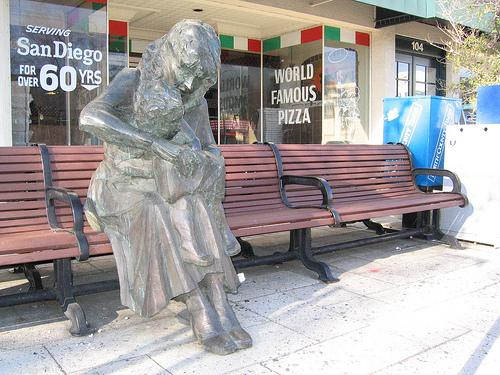Question: where are the benches sitting?
Choices:
A. Sidewalk.
B. Park.
C. Outside a store.
D. Nature trail.
Answer with the letter. Answer: C 